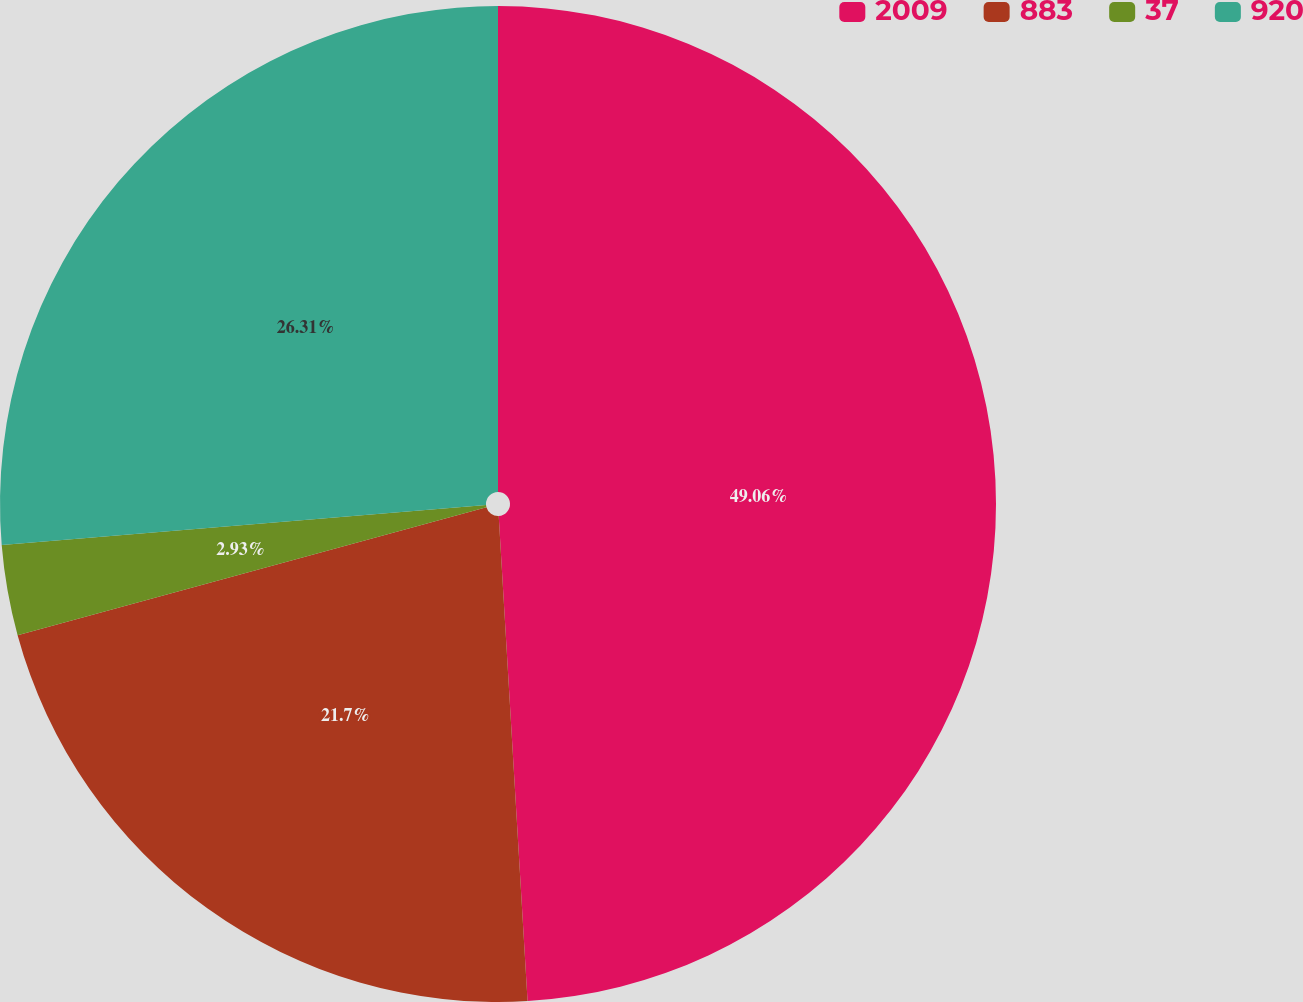Convert chart to OTSL. <chart><loc_0><loc_0><loc_500><loc_500><pie_chart><fcel>2009<fcel>883<fcel>37<fcel>920<nl><fcel>49.05%<fcel>21.7%<fcel>2.93%<fcel>26.31%<nl></chart> 